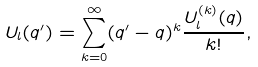Convert formula to latex. <formula><loc_0><loc_0><loc_500><loc_500>U _ { l } ( q ^ { \prime } ) = \sum _ { k = 0 } ^ { \infty } ( q ^ { \prime } - q ) ^ { k } \frac { U _ { l } ^ { ( k ) } ( q ) } { k ! } ,</formula> 